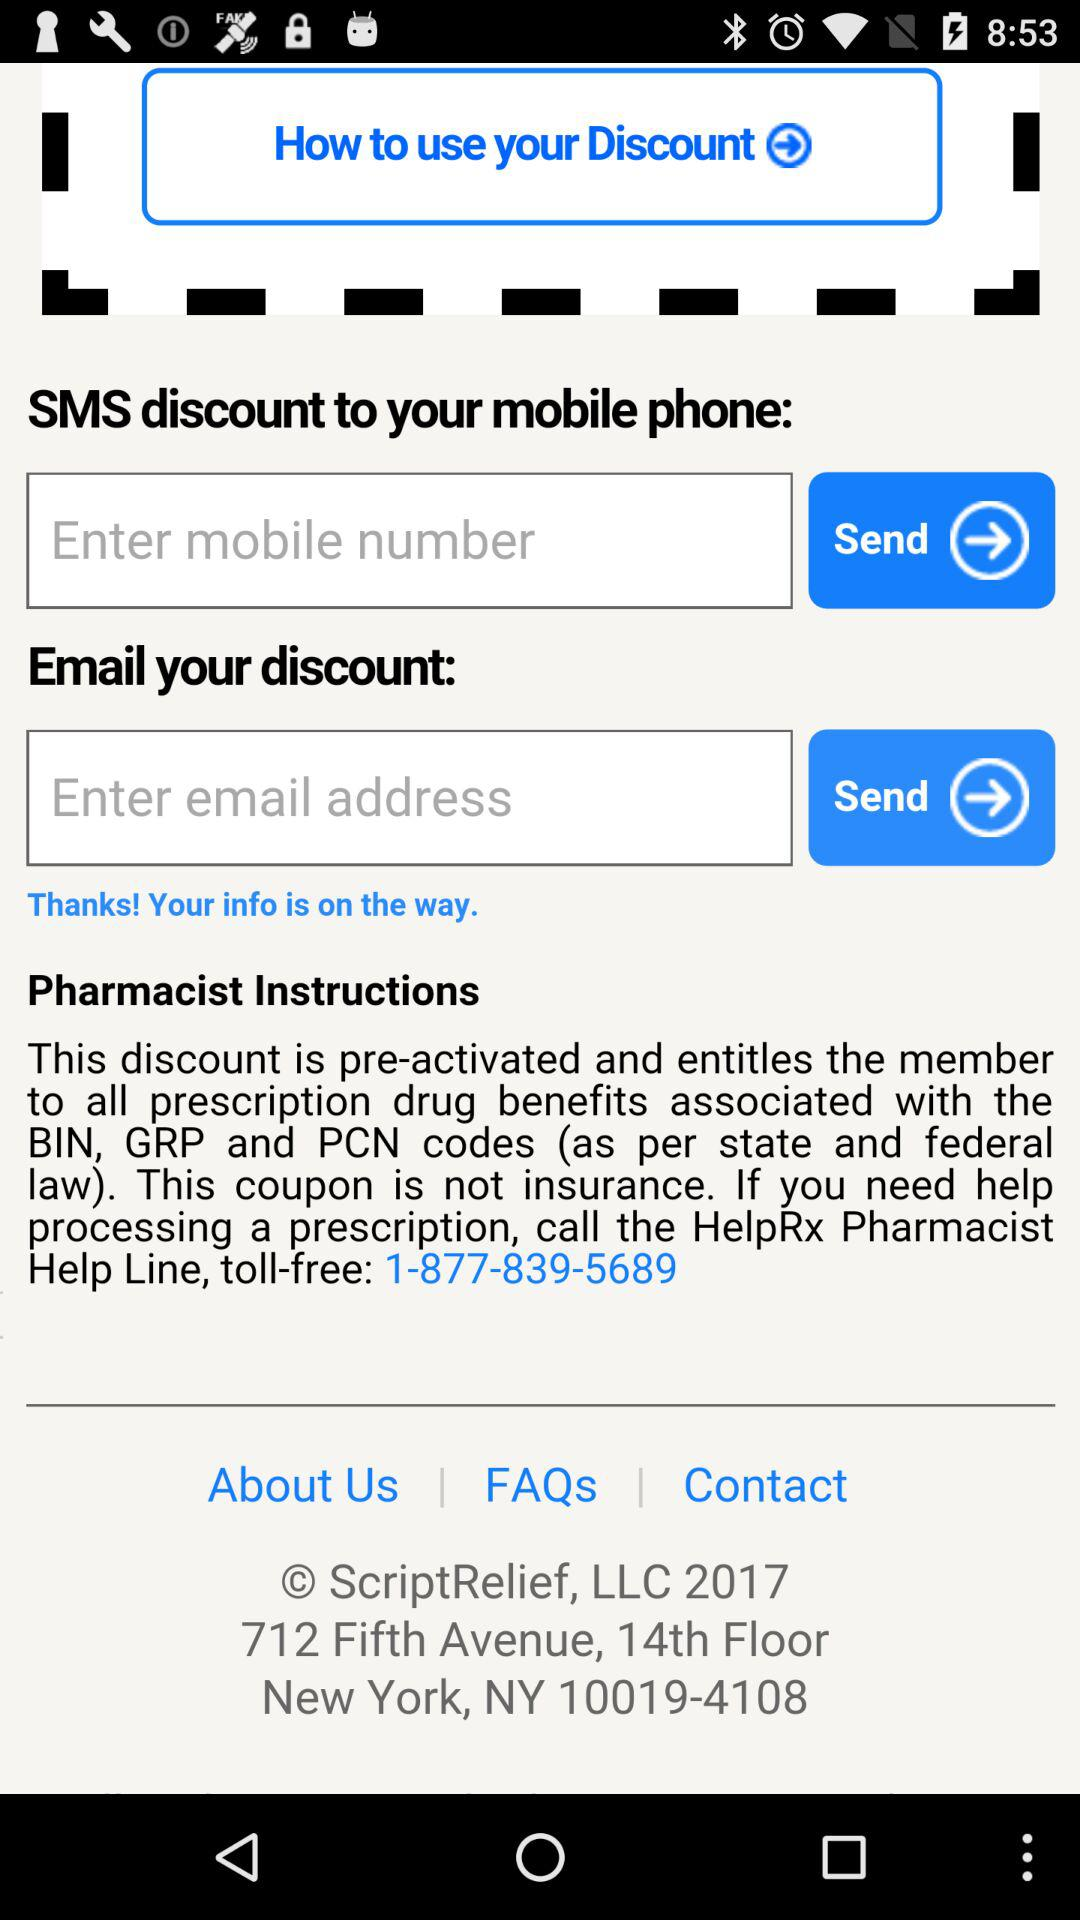What is the address on the screen? The address is 712 Fifth Avenue, 14th Floor New York, NY 10019-4108. 